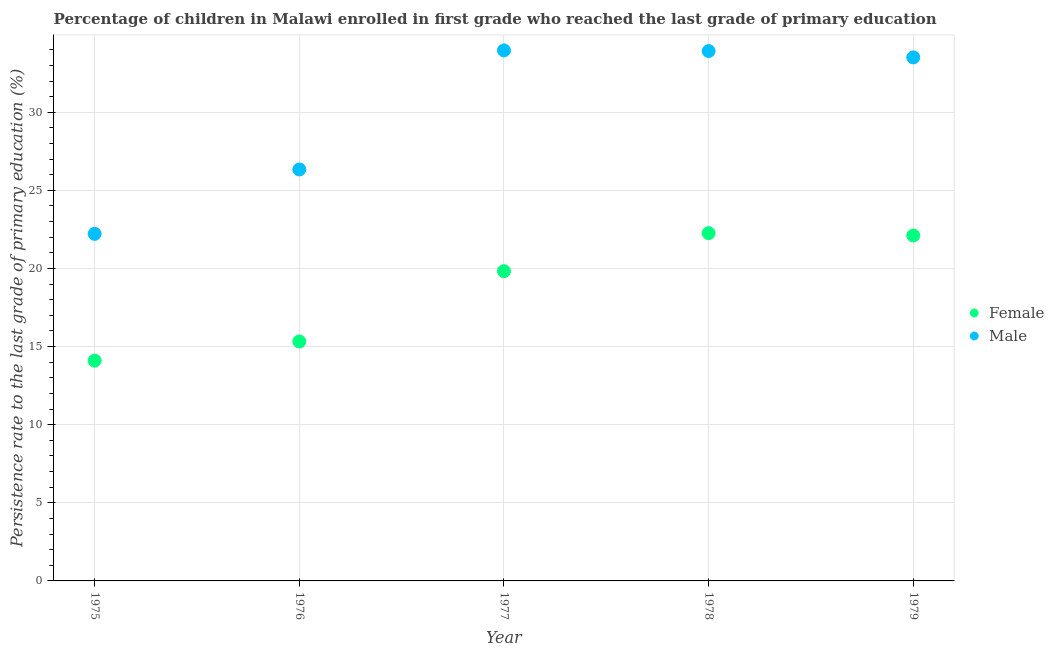How many different coloured dotlines are there?
Your response must be concise. 2. Is the number of dotlines equal to the number of legend labels?
Offer a very short reply. Yes. What is the persistence rate of male students in 1975?
Provide a succinct answer. 22.22. Across all years, what is the maximum persistence rate of male students?
Offer a terse response. 33.96. Across all years, what is the minimum persistence rate of female students?
Offer a terse response. 14.1. In which year was the persistence rate of female students maximum?
Give a very brief answer. 1978. In which year was the persistence rate of female students minimum?
Keep it short and to the point. 1975. What is the total persistence rate of female students in the graph?
Your answer should be very brief. 93.63. What is the difference between the persistence rate of male students in 1975 and that in 1979?
Provide a succinct answer. -11.3. What is the difference between the persistence rate of male students in 1978 and the persistence rate of female students in 1977?
Offer a terse response. 14.09. What is the average persistence rate of male students per year?
Keep it short and to the point. 29.99. In the year 1979, what is the difference between the persistence rate of male students and persistence rate of female students?
Offer a terse response. 11.4. What is the ratio of the persistence rate of female students in 1975 to that in 1976?
Make the answer very short. 0.92. Is the difference between the persistence rate of female students in 1978 and 1979 greater than the difference between the persistence rate of male students in 1978 and 1979?
Your answer should be compact. No. What is the difference between the highest and the second highest persistence rate of female students?
Provide a succinct answer. 0.15. What is the difference between the highest and the lowest persistence rate of female students?
Your answer should be very brief. 8.16. Is the sum of the persistence rate of male students in 1977 and 1979 greater than the maximum persistence rate of female students across all years?
Offer a very short reply. Yes. Does the persistence rate of female students monotonically increase over the years?
Your answer should be very brief. No. Is the persistence rate of female students strictly greater than the persistence rate of male students over the years?
Your answer should be compact. No. Does the graph contain grids?
Your answer should be very brief. Yes. What is the title of the graph?
Your response must be concise. Percentage of children in Malawi enrolled in first grade who reached the last grade of primary education. What is the label or title of the X-axis?
Ensure brevity in your answer.  Year. What is the label or title of the Y-axis?
Offer a very short reply. Persistence rate to the last grade of primary education (%). What is the Persistence rate to the last grade of primary education (%) of Female in 1975?
Your answer should be compact. 14.1. What is the Persistence rate to the last grade of primary education (%) of Male in 1975?
Your response must be concise. 22.22. What is the Persistence rate to the last grade of primary education (%) of Female in 1976?
Give a very brief answer. 15.33. What is the Persistence rate to the last grade of primary education (%) in Male in 1976?
Keep it short and to the point. 26.34. What is the Persistence rate to the last grade of primary education (%) of Female in 1977?
Keep it short and to the point. 19.83. What is the Persistence rate to the last grade of primary education (%) of Male in 1977?
Offer a terse response. 33.96. What is the Persistence rate to the last grade of primary education (%) in Female in 1978?
Provide a short and direct response. 22.26. What is the Persistence rate to the last grade of primary education (%) in Male in 1978?
Provide a short and direct response. 33.92. What is the Persistence rate to the last grade of primary education (%) in Female in 1979?
Offer a terse response. 22.11. What is the Persistence rate to the last grade of primary education (%) of Male in 1979?
Make the answer very short. 33.51. Across all years, what is the maximum Persistence rate to the last grade of primary education (%) in Female?
Ensure brevity in your answer.  22.26. Across all years, what is the maximum Persistence rate to the last grade of primary education (%) in Male?
Ensure brevity in your answer.  33.96. Across all years, what is the minimum Persistence rate to the last grade of primary education (%) of Female?
Offer a very short reply. 14.1. Across all years, what is the minimum Persistence rate to the last grade of primary education (%) of Male?
Provide a short and direct response. 22.22. What is the total Persistence rate to the last grade of primary education (%) in Female in the graph?
Ensure brevity in your answer.  93.63. What is the total Persistence rate to the last grade of primary education (%) in Male in the graph?
Provide a short and direct response. 149.94. What is the difference between the Persistence rate to the last grade of primary education (%) of Female in 1975 and that in 1976?
Give a very brief answer. -1.23. What is the difference between the Persistence rate to the last grade of primary education (%) of Male in 1975 and that in 1976?
Offer a very short reply. -4.12. What is the difference between the Persistence rate to the last grade of primary education (%) of Female in 1975 and that in 1977?
Provide a short and direct response. -5.73. What is the difference between the Persistence rate to the last grade of primary education (%) of Male in 1975 and that in 1977?
Make the answer very short. -11.74. What is the difference between the Persistence rate to the last grade of primary education (%) in Female in 1975 and that in 1978?
Provide a short and direct response. -8.16. What is the difference between the Persistence rate to the last grade of primary education (%) in Male in 1975 and that in 1978?
Your response must be concise. -11.7. What is the difference between the Persistence rate to the last grade of primary education (%) of Female in 1975 and that in 1979?
Ensure brevity in your answer.  -8.01. What is the difference between the Persistence rate to the last grade of primary education (%) of Male in 1975 and that in 1979?
Your answer should be very brief. -11.3. What is the difference between the Persistence rate to the last grade of primary education (%) in Female in 1976 and that in 1977?
Provide a short and direct response. -4.5. What is the difference between the Persistence rate to the last grade of primary education (%) of Male in 1976 and that in 1977?
Provide a short and direct response. -7.62. What is the difference between the Persistence rate to the last grade of primary education (%) in Female in 1976 and that in 1978?
Your answer should be very brief. -6.93. What is the difference between the Persistence rate to the last grade of primary education (%) in Male in 1976 and that in 1978?
Your answer should be very brief. -7.58. What is the difference between the Persistence rate to the last grade of primary education (%) of Female in 1976 and that in 1979?
Keep it short and to the point. -6.78. What is the difference between the Persistence rate to the last grade of primary education (%) of Male in 1976 and that in 1979?
Provide a succinct answer. -7.17. What is the difference between the Persistence rate to the last grade of primary education (%) in Female in 1977 and that in 1978?
Provide a succinct answer. -2.43. What is the difference between the Persistence rate to the last grade of primary education (%) of Male in 1977 and that in 1978?
Ensure brevity in your answer.  0.04. What is the difference between the Persistence rate to the last grade of primary education (%) in Female in 1977 and that in 1979?
Your response must be concise. -2.29. What is the difference between the Persistence rate to the last grade of primary education (%) of Male in 1977 and that in 1979?
Your response must be concise. 0.45. What is the difference between the Persistence rate to the last grade of primary education (%) of Female in 1978 and that in 1979?
Provide a short and direct response. 0.15. What is the difference between the Persistence rate to the last grade of primary education (%) of Male in 1978 and that in 1979?
Keep it short and to the point. 0.4. What is the difference between the Persistence rate to the last grade of primary education (%) in Female in 1975 and the Persistence rate to the last grade of primary education (%) in Male in 1976?
Your answer should be very brief. -12.24. What is the difference between the Persistence rate to the last grade of primary education (%) in Female in 1975 and the Persistence rate to the last grade of primary education (%) in Male in 1977?
Provide a short and direct response. -19.86. What is the difference between the Persistence rate to the last grade of primary education (%) of Female in 1975 and the Persistence rate to the last grade of primary education (%) of Male in 1978?
Provide a short and direct response. -19.82. What is the difference between the Persistence rate to the last grade of primary education (%) in Female in 1975 and the Persistence rate to the last grade of primary education (%) in Male in 1979?
Your response must be concise. -19.41. What is the difference between the Persistence rate to the last grade of primary education (%) in Female in 1976 and the Persistence rate to the last grade of primary education (%) in Male in 1977?
Make the answer very short. -18.63. What is the difference between the Persistence rate to the last grade of primary education (%) in Female in 1976 and the Persistence rate to the last grade of primary education (%) in Male in 1978?
Offer a terse response. -18.59. What is the difference between the Persistence rate to the last grade of primary education (%) of Female in 1976 and the Persistence rate to the last grade of primary education (%) of Male in 1979?
Provide a short and direct response. -18.19. What is the difference between the Persistence rate to the last grade of primary education (%) of Female in 1977 and the Persistence rate to the last grade of primary education (%) of Male in 1978?
Your answer should be compact. -14.09. What is the difference between the Persistence rate to the last grade of primary education (%) of Female in 1977 and the Persistence rate to the last grade of primary education (%) of Male in 1979?
Offer a very short reply. -13.69. What is the difference between the Persistence rate to the last grade of primary education (%) in Female in 1978 and the Persistence rate to the last grade of primary education (%) in Male in 1979?
Your response must be concise. -11.25. What is the average Persistence rate to the last grade of primary education (%) of Female per year?
Offer a terse response. 18.73. What is the average Persistence rate to the last grade of primary education (%) of Male per year?
Ensure brevity in your answer.  29.99. In the year 1975, what is the difference between the Persistence rate to the last grade of primary education (%) of Female and Persistence rate to the last grade of primary education (%) of Male?
Ensure brevity in your answer.  -8.12. In the year 1976, what is the difference between the Persistence rate to the last grade of primary education (%) in Female and Persistence rate to the last grade of primary education (%) in Male?
Your response must be concise. -11.01. In the year 1977, what is the difference between the Persistence rate to the last grade of primary education (%) of Female and Persistence rate to the last grade of primary education (%) of Male?
Your answer should be very brief. -14.13. In the year 1978, what is the difference between the Persistence rate to the last grade of primary education (%) of Female and Persistence rate to the last grade of primary education (%) of Male?
Offer a very short reply. -11.66. In the year 1979, what is the difference between the Persistence rate to the last grade of primary education (%) in Female and Persistence rate to the last grade of primary education (%) in Male?
Offer a very short reply. -11.4. What is the ratio of the Persistence rate to the last grade of primary education (%) of Female in 1975 to that in 1976?
Your response must be concise. 0.92. What is the ratio of the Persistence rate to the last grade of primary education (%) of Male in 1975 to that in 1976?
Your response must be concise. 0.84. What is the ratio of the Persistence rate to the last grade of primary education (%) of Female in 1975 to that in 1977?
Ensure brevity in your answer.  0.71. What is the ratio of the Persistence rate to the last grade of primary education (%) of Male in 1975 to that in 1977?
Your response must be concise. 0.65. What is the ratio of the Persistence rate to the last grade of primary education (%) in Female in 1975 to that in 1978?
Keep it short and to the point. 0.63. What is the ratio of the Persistence rate to the last grade of primary education (%) of Male in 1975 to that in 1978?
Give a very brief answer. 0.66. What is the ratio of the Persistence rate to the last grade of primary education (%) of Female in 1975 to that in 1979?
Offer a terse response. 0.64. What is the ratio of the Persistence rate to the last grade of primary education (%) of Male in 1975 to that in 1979?
Keep it short and to the point. 0.66. What is the ratio of the Persistence rate to the last grade of primary education (%) in Female in 1976 to that in 1977?
Your answer should be compact. 0.77. What is the ratio of the Persistence rate to the last grade of primary education (%) in Male in 1976 to that in 1977?
Offer a terse response. 0.78. What is the ratio of the Persistence rate to the last grade of primary education (%) in Female in 1976 to that in 1978?
Provide a succinct answer. 0.69. What is the ratio of the Persistence rate to the last grade of primary education (%) in Male in 1976 to that in 1978?
Your answer should be very brief. 0.78. What is the ratio of the Persistence rate to the last grade of primary education (%) in Female in 1976 to that in 1979?
Make the answer very short. 0.69. What is the ratio of the Persistence rate to the last grade of primary education (%) in Male in 1976 to that in 1979?
Your answer should be very brief. 0.79. What is the ratio of the Persistence rate to the last grade of primary education (%) of Female in 1977 to that in 1978?
Offer a very short reply. 0.89. What is the ratio of the Persistence rate to the last grade of primary education (%) of Female in 1977 to that in 1979?
Make the answer very short. 0.9. What is the ratio of the Persistence rate to the last grade of primary education (%) in Male in 1977 to that in 1979?
Provide a short and direct response. 1.01. What is the ratio of the Persistence rate to the last grade of primary education (%) in Female in 1978 to that in 1979?
Offer a very short reply. 1.01. What is the ratio of the Persistence rate to the last grade of primary education (%) of Male in 1978 to that in 1979?
Your response must be concise. 1.01. What is the difference between the highest and the second highest Persistence rate to the last grade of primary education (%) of Female?
Provide a short and direct response. 0.15. What is the difference between the highest and the second highest Persistence rate to the last grade of primary education (%) in Male?
Provide a succinct answer. 0.04. What is the difference between the highest and the lowest Persistence rate to the last grade of primary education (%) in Female?
Offer a very short reply. 8.16. What is the difference between the highest and the lowest Persistence rate to the last grade of primary education (%) in Male?
Make the answer very short. 11.74. 